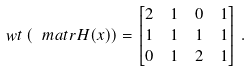<formula> <loc_0><loc_0><loc_500><loc_500>\ w t \left ( \ m a t r { H } ( x ) \right ) & = \begin{bmatrix} 2 & 1 & 0 & 1 \\ 1 & 1 & 1 & 1 \\ 0 & 1 & 2 & 1 \end{bmatrix} \, .</formula> 